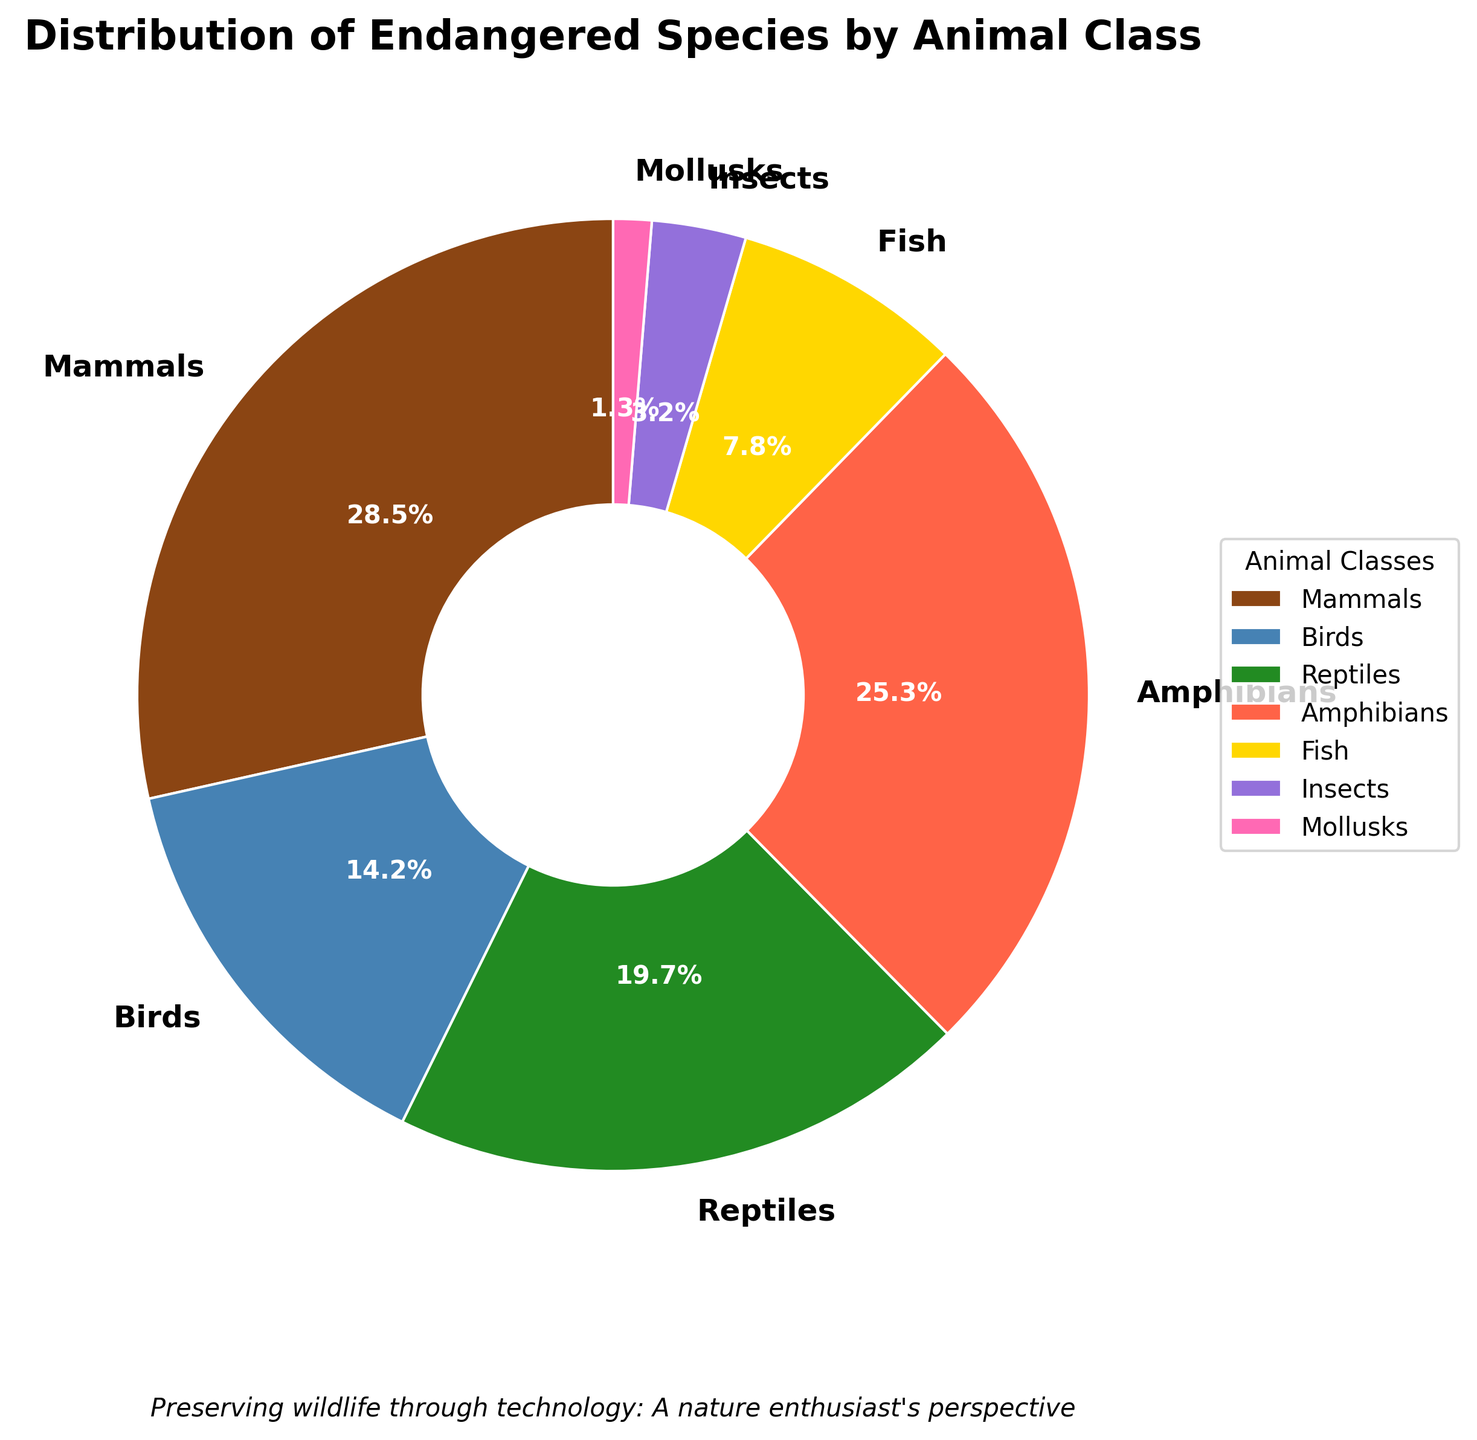What is the proportion of Mammals among the endangered species? Mammals have a percentage value of 28.5% labeled on the pie chart. This shows their proportion directly.
Answer: 28.5% Which animal class has the smallest proportion of endangered species? Examine all the labeled percentages on the pie chart. Mollusks (1.3%) have the smallest proportion among the listed classes.
Answer: Mollusks Are there more endangered amphibians or reptiles? Compare the percentages of amphibians (25.3%) with reptiles (19.7%). Amphibians have a higher percentage.
Answer: Amphibians What is the combined proportion of endangered Fish and Insects? Add the percentages of Fish (7.8%) and Insects (3.2%). The combined proportion is 7.8% + 3.2% = 11%.
Answer: 11% Which animal class has a higher percentage of endangered species, Birds or Insects? Compare the percentages of Birds (14.2%) with Insects (3.2%). Birds have a higher percentage.
Answer: Birds What is the difference in proportions between the class with the highest and the class with the lowest percentages? Identify the highest (Mammals at 28.5%) and the lowest (Mollusks at 1.3%) percentages and subtract the latter from the former: 28.5% - 1.3% = 27.2%.
Answer: 27.2% What is the total percentage of endangered species accounted for by Mammals, Birds, and Reptiles? Sum the percentages of Mammals (28.5%), Birds (14.2%), and Reptiles (19.7%). The total is 28.5% + 14.2% + 19.7% = 62.4%.
Answer: 62.4% How much more is the percentage share of endangered species by Amphibians compared to Fish? Subtract the percentage of Fish (7.8%) from that of Amphibians (25.3%): 25.3% - 7.8% = 17.5%.
Answer: 17.5% What color represents the Reptiles on the pie chart? Look at the color assigned to Reptiles in the pie chart. By cross-referencing the index, Reptiles are represented by green.
Answer: Green Which two animal classes have percentages that sum up to around 50% of the endangered species? Identify suitable pairs. Amphibians (25.3%) and Reptiles (19.7%) together make 25.3% + 19.7% = 45%. Although not exactly 50%, they are closest compared to other pairs.
Answer: Amphibians and Reptiles 